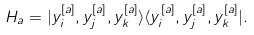<formula> <loc_0><loc_0><loc_500><loc_500>H _ { a } = | y ^ { [ a ] } _ { i } , y ^ { [ a ] } _ { j } , y ^ { [ a ] } _ { k } \rangle \langle y ^ { [ a ] } _ { i } , y ^ { [ a ] } _ { j } , y ^ { [ a ] } _ { k } | .</formula> 